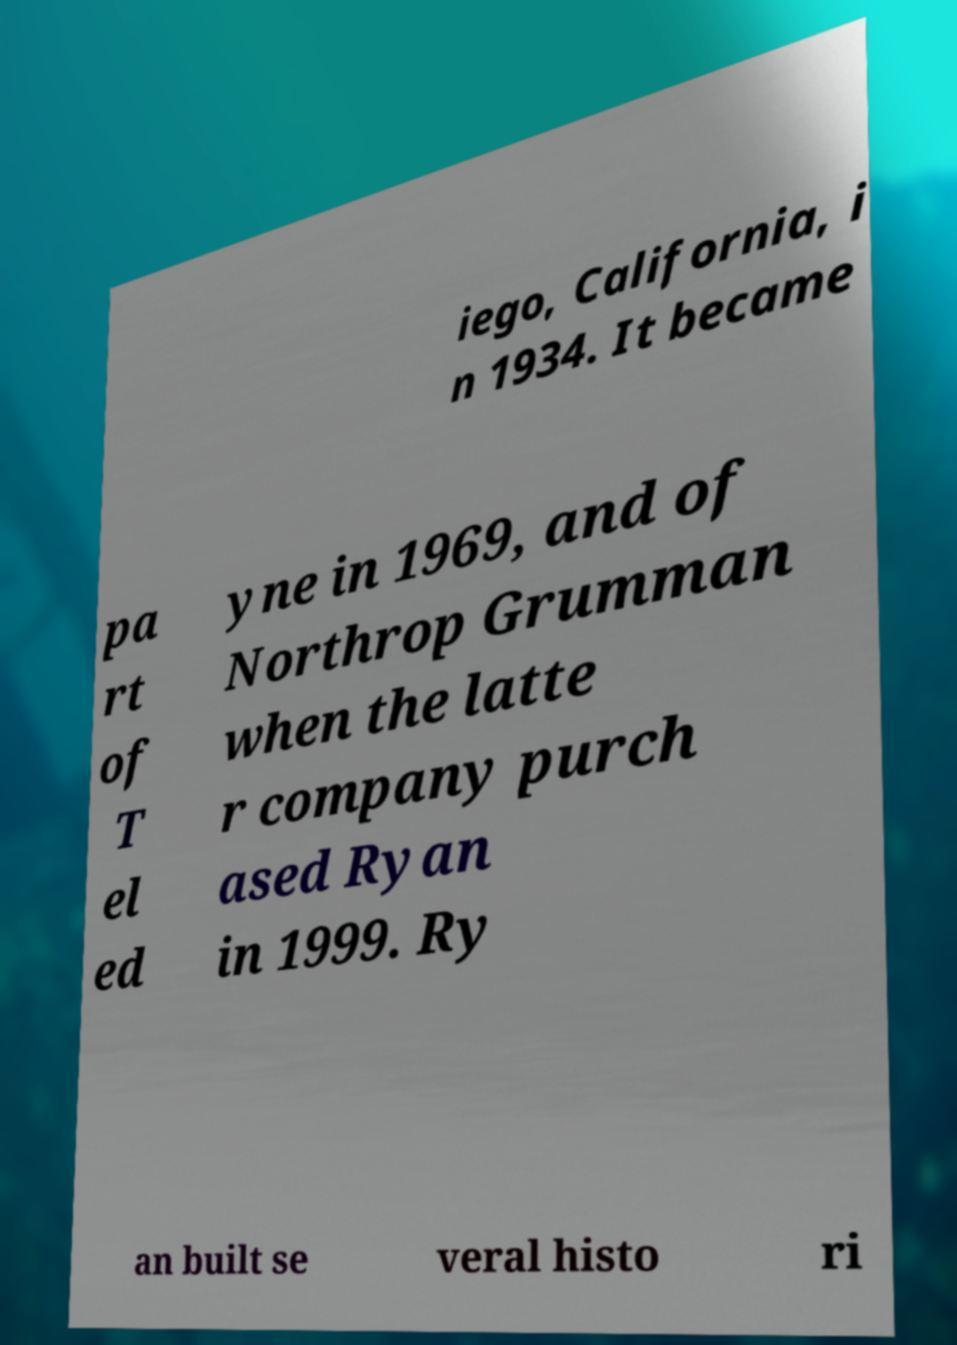Can you accurately transcribe the text from the provided image for me? iego, California, i n 1934. It became pa rt of T el ed yne in 1969, and of Northrop Grumman when the latte r company purch ased Ryan in 1999. Ry an built se veral histo ri 